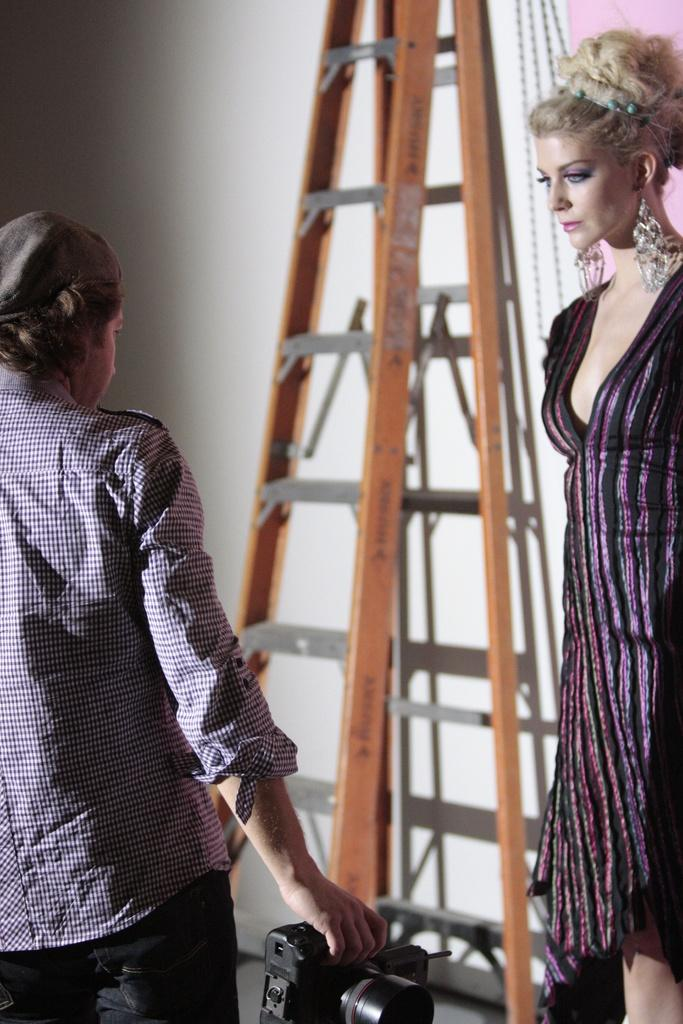Who are the people in the image? There is a man and a woman in the image. What is the man holding in the image? The man is holding a camera in the image. What can be seen in the background of the image? There is a wall and a ladder in the background of the image. What is the income of the man in the image? There is no information about the man's income in the image. How long does the show last in the image? There is no show or time duration mentioned in the image. 